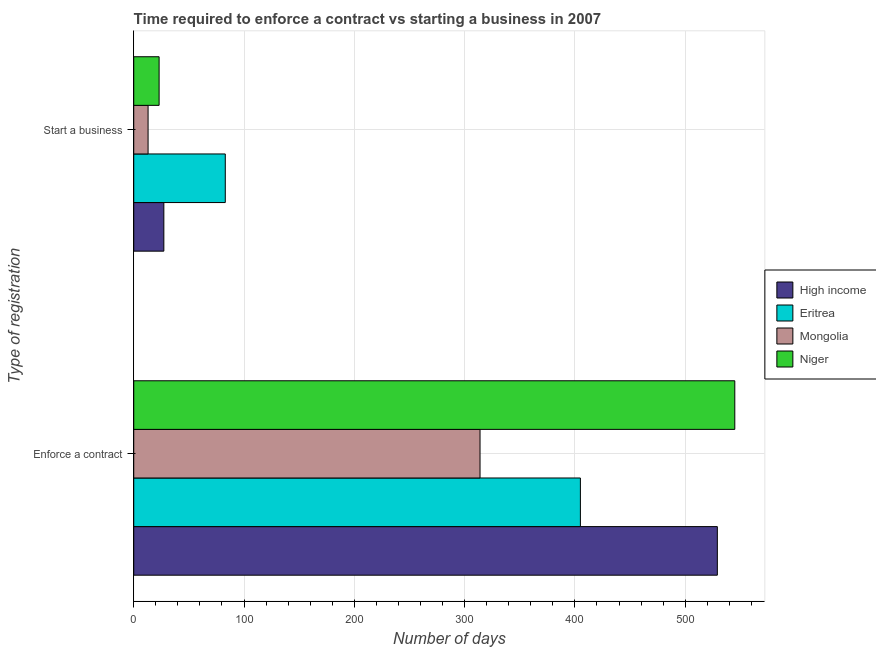How many groups of bars are there?
Your response must be concise. 2. How many bars are there on the 2nd tick from the bottom?
Keep it short and to the point. 4. What is the label of the 1st group of bars from the top?
Keep it short and to the point. Start a business. Across all countries, what is the maximum number of days to start a business?
Give a very brief answer. 83. In which country was the number of days to enforece a contract maximum?
Provide a succinct answer. Niger. In which country was the number of days to enforece a contract minimum?
Give a very brief answer. Mongolia. What is the total number of days to start a business in the graph?
Offer a very short reply. 146.3. What is the difference between the number of days to start a business in Eritrea and the number of days to enforece a contract in Mongolia?
Offer a very short reply. -231. What is the average number of days to enforece a contract per country?
Provide a succinct answer. 448.29. What is the difference between the number of days to start a business and number of days to enforece a contract in Eritrea?
Keep it short and to the point. -322. What is the ratio of the number of days to enforece a contract in Mongolia to that in Niger?
Offer a very short reply. 0.58. What does the 4th bar from the top in Enforce a contract represents?
Offer a very short reply. High income. What does the 2nd bar from the bottom in Start a business represents?
Ensure brevity in your answer.  Eritrea. Are all the bars in the graph horizontal?
Ensure brevity in your answer.  Yes. How many countries are there in the graph?
Your response must be concise. 4. What is the difference between two consecutive major ticks on the X-axis?
Provide a succinct answer. 100. Does the graph contain any zero values?
Make the answer very short. No. Does the graph contain grids?
Offer a very short reply. Yes. Where does the legend appear in the graph?
Offer a terse response. Center right. How many legend labels are there?
Ensure brevity in your answer.  4. How are the legend labels stacked?
Provide a short and direct response. Vertical. What is the title of the graph?
Offer a terse response. Time required to enforce a contract vs starting a business in 2007. Does "Tanzania" appear as one of the legend labels in the graph?
Keep it short and to the point. No. What is the label or title of the X-axis?
Your answer should be compact. Number of days. What is the label or title of the Y-axis?
Give a very brief answer. Type of registration. What is the Number of days of High income in Enforce a contract?
Provide a succinct answer. 529.17. What is the Number of days in Eritrea in Enforce a contract?
Provide a short and direct response. 405. What is the Number of days of Mongolia in Enforce a contract?
Offer a very short reply. 314. What is the Number of days in Niger in Enforce a contract?
Offer a very short reply. 545. What is the Number of days of High income in Start a business?
Your response must be concise. 27.3. What is the Number of days of Eritrea in Start a business?
Your answer should be very brief. 83. What is the Number of days in Niger in Start a business?
Your answer should be very brief. 23. Across all Type of registration, what is the maximum Number of days in High income?
Offer a very short reply. 529.17. Across all Type of registration, what is the maximum Number of days of Eritrea?
Keep it short and to the point. 405. Across all Type of registration, what is the maximum Number of days of Mongolia?
Ensure brevity in your answer.  314. Across all Type of registration, what is the maximum Number of days in Niger?
Give a very brief answer. 545. Across all Type of registration, what is the minimum Number of days in High income?
Give a very brief answer. 27.3. Across all Type of registration, what is the minimum Number of days in Eritrea?
Your answer should be compact. 83. What is the total Number of days in High income in the graph?
Ensure brevity in your answer.  556.47. What is the total Number of days in Eritrea in the graph?
Make the answer very short. 488. What is the total Number of days in Mongolia in the graph?
Offer a very short reply. 327. What is the total Number of days of Niger in the graph?
Make the answer very short. 568. What is the difference between the Number of days of High income in Enforce a contract and that in Start a business?
Give a very brief answer. 501.87. What is the difference between the Number of days of Eritrea in Enforce a contract and that in Start a business?
Your response must be concise. 322. What is the difference between the Number of days of Mongolia in Enforce a contract and that in Start a business?
Offer a terse response. 301. What is the difference between the Number of days in Niger in Enforce a contract and that in Start a business?
Provide a short and direct response. 522. What is the difference between the Number of days in High income in Enforce a contract and the Number of days in Eritrea in Start a business?
Make the answer very short. 446.17. What is the difference between the Number of days in High income in Enforce a contract and the Number of days in Mongolia in Start a business?
Offer a terse response. 516.17. What is the difference between the Number of days in High income in Enforce a contract and the Number of days in Niger in Start a business?
Offer a terse response. 506.17. What is the difference between the Number of days of Eritrea in Enforce a contract and the Number of days of Mongolia in Start a business?
Make the answer very short. 392. What is the difference between the Number of days in Eritrea in Enforce a contract and the Number of days in Niger in Start a business?
Your answer should be compact. 382. What is the difference between the Number of days of Mongolia in Enforce a contract and the Number of days of Niger in Start a business?
Your answer should be very brief. 291. What is the average Number of days in High income per Type of registration?
Keep it short and to the point. 278.24. What is the average Number of days in Eritrea per Type of registration?
Provide a short and direct response. 244. What is the average Number of days of Mongolia per Type of registration?
Provide a succinct answer. 163.5. What is the average Number of days in Niger per Type of registration?
Your answer should be very brief. 284. What is the difference between the Number of days in High income and Number of days in Eritrea in Enforce a contract?
Your answer should be very brief. 124.17. What is the difference between the Number of days of High income and Number of days of Mongolia in Enforce a contract?
Offer a very short reply. 215.17. What is the difference between the Number of days of High income and Number of days of Niger in Enforce a contract?
Your response must be concise. -15.83. What is the difference between the Number of days of Eritrea and Number of days of Mongolia in Enforce a contract?
Provide a succinct answer. 91. What is the difference between the Number of days in Eritrea and Number of days in Niger in Enforce a contract?
Ensure brevity in your answer.  -140. What is the difference between the Number of days of Mongolia and Number of days of Niger in Enforce a contract?
Provide a short and direct response. -231. What is the difference between the Number of days in High income and Number of days in Eritrea in Start a business?
Offer a very short reply. -55.7. What is the difference between the Number of days in High income and Number of days in Mongolia in Start a business?
Give a very brief answer. 14.3. What is the difference between the Number of days of High income and Number of days of Niger in Start a business?
Your answer should be very brief. 4.3. What is the difference between the Number of days of Eritrea and Number of days of Niger in Start a business?
Give a very brief answer. 60. What is the difference between the Number of days of Mongolia and Number of days of Niger in Start a business?
Your answer should be compact. -10. What is the ratio of the Number of days in High income in Enforce a contract to that in Start a business?
Ensure brevity in your answer.  19.38. What is the ratio of the Number of days of Eritrea in Enforce a contract to that in Start a business?
Keep it short and to the point. 4.88. What is the ratio of the Number of days in Mongolia in Enforce a contract to that in Start a business?
Offer a very short reply. 24.15. What is the ratio of the Number of days in Niger in Enforce a contract to that in Start a business?
Provide a succinct answer. 23.7. What is the difference between the highest and the second highest Number of days in High income?
Your answer should be very brief. 501.87. What is the difference between the highest and the second highest Number of days of Eritrea?
Make the answer very short. 322. What is the difference between the highest and the second highest Number of days of Mongolia?
Your response must be concise. 301. What is the difference between the highest and the second highest Number of days of Niger?
Your answer should be very brief. 522. What is the difference between the highest and the lowest Number of days of High income?
Provide a short and direct response. 501.87. What is the difference between the highest and the lowest Number of days in Eritrea?
Keep it short and to the point. 322. What is the difference between the highest and the lowest Number of days in Mongolia?
Make the answer very short. 301. What is the difference between the highest and the lowest Number of days of Niger?
Your answer should be compact. 522. 